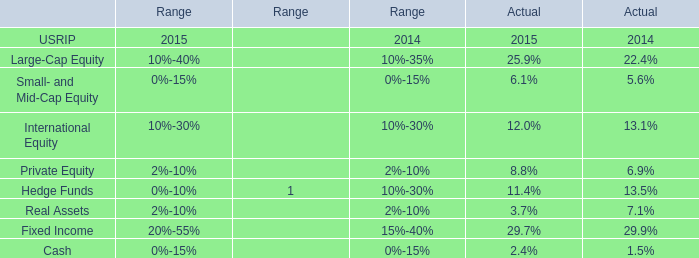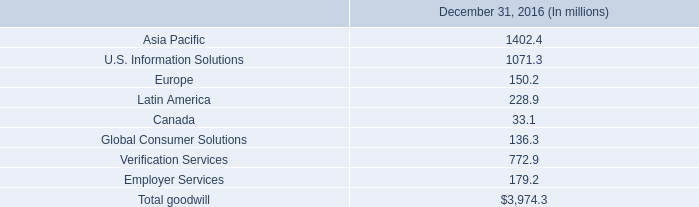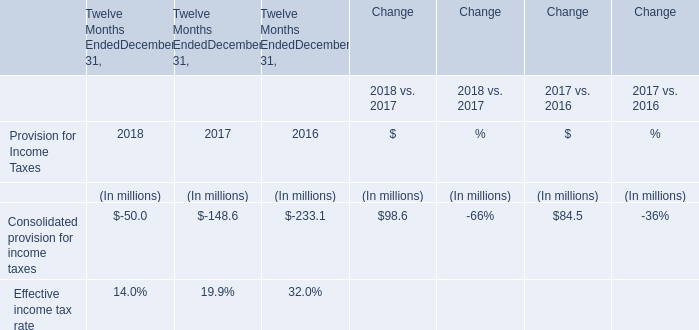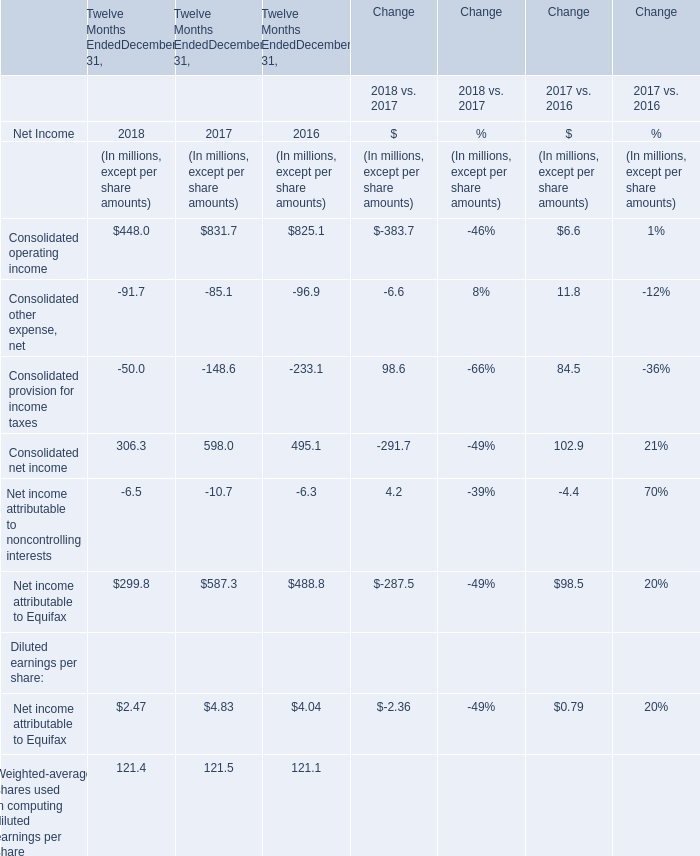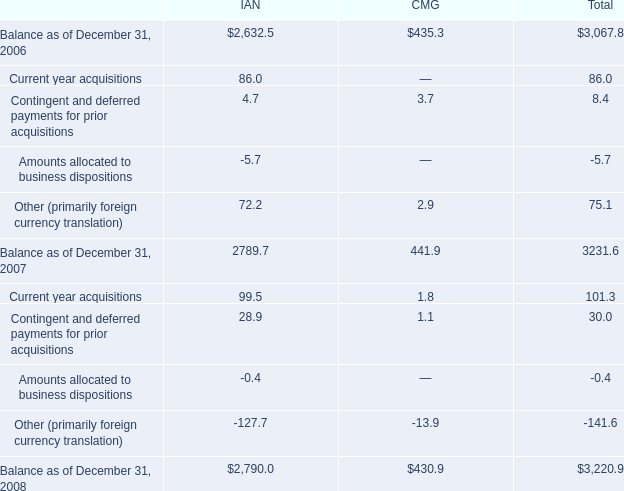what was the percentage change in total goodwill carrying value from 2007 to 2008? 
Computations: ((3220.9 - 3231.6) / 3231.6)
Answer: -0.00331. 